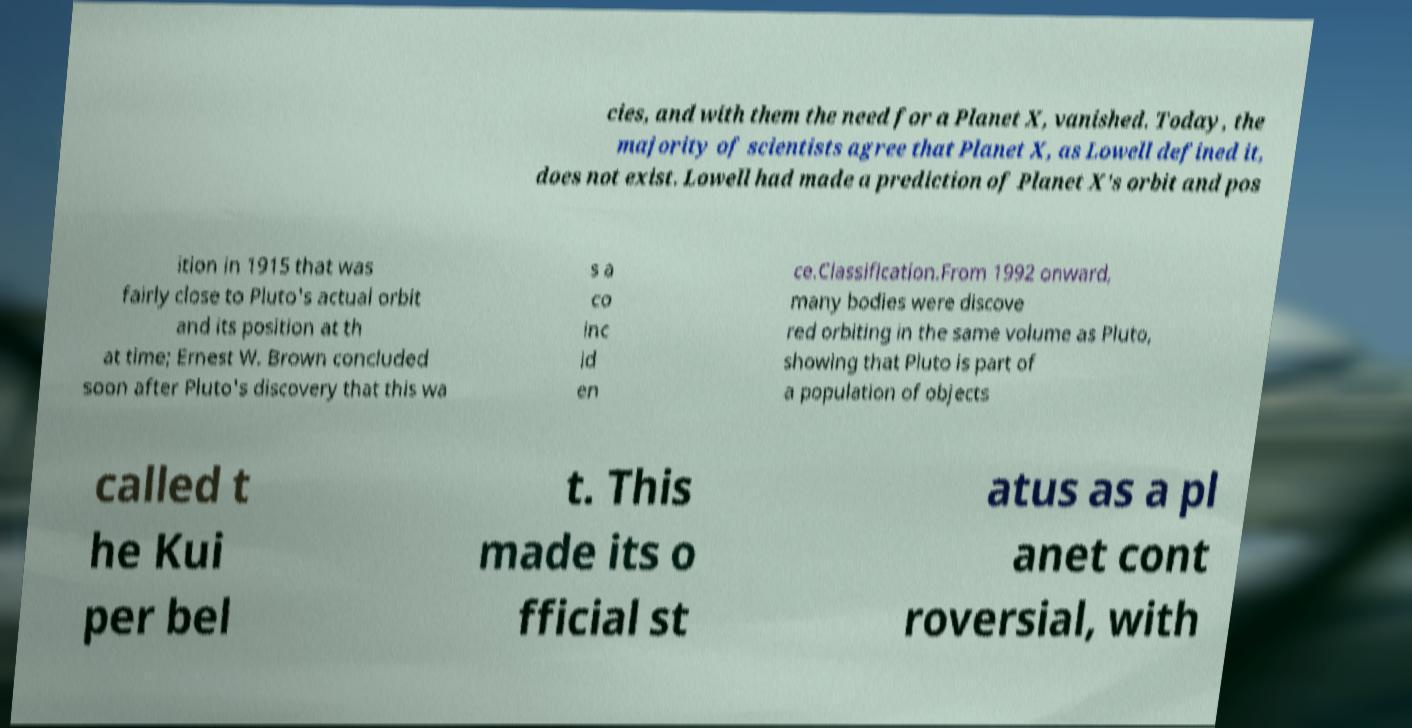For documentation purposes, I need the text within this image transcribed. Could you provide that? cies, and with them the need for a Planet X, vanished. Today, the majority of scientists agree that Planet X, as Lowell defined it, does not exist. Lowell had made a prediction of Planet X's orbit and pos ition in 1915 that was fairly close to Pluto's actual orbit and its position at th at time; Ernest W. Brown concluded soon after Pluto's discovery that this wa s a co inc id en ce.Classification.From 1992 onward, many bodies were discove red orbiting in the same volume as Pluto, showing that Pluto is part of a population of objects called t he Kui per bel t. This made its o fficial st atus as a pl anet cont roversial, with 